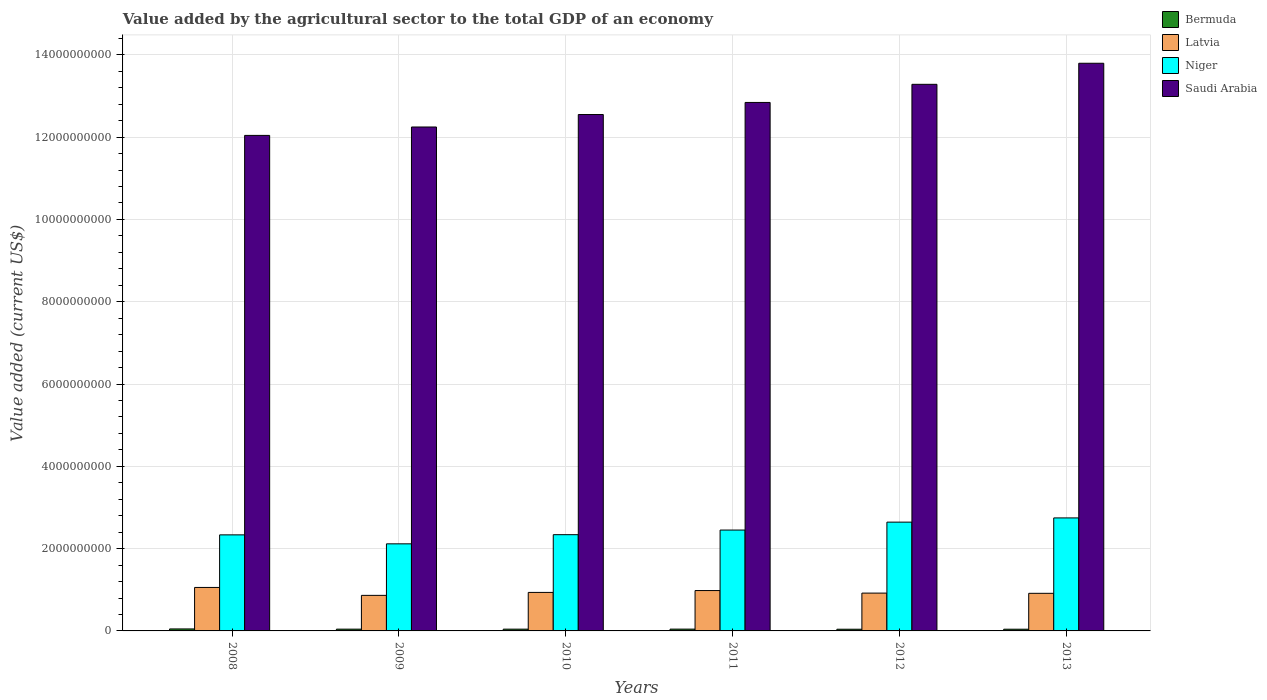How many different coloured bars are there?
Offer a terse response. 4. How many groups of bars are there?
Your answer should be compact. 6. Are the number of bars per tick equal to the number of legend labels?
Make the answer very short. Yes. Are the number of bars on each tick of the X-axis equal?
Offer a very short reply. Yes. What is the value added by the agricultural sector to the total GDP in Saudi Arabia in 2013?
Offer a terse response. 1.38e+1. Across all years, what is the maximum value added by the agricultural sector to the total GDP in Saudi Arabia?
Ensure brevity in your answer.  1.38e+1. Across all years, what is the minimum value added by the agricultural sector to the total GDP in Saudi Arabia?
Give a very brief answer. 1.20e+1. In which year was the value added by the agricultural sector to the total GDP in Latvia minimum?
Offer a terse response. 2009. What is the total value added by the agricultural sector to the total GDP in Saudi Arabia in the graph?
Provide a short and direct response. 7.68e+1. What is the difference between the value added by the agricultural sector to the total GDP in Niger in 2009 and that in 2013?
Make the answer very short. -6.30e+08. What is the difference between the value added by the agricultural sector to the total GDP in Saudi Arabia in 2011 and the value added by the agricultural sector to the total GDP in Bermuda in 2009?
Provide a short and direct response. 1.28e+1. What is the average value added by the agricultural sector to the total GDP in Latvia per year?
Ensure brevity in your answer.  9.45e+08. In the year 2013, what is the difference between the value added by the agricultural sector to the total GDP in Niger and value added by the agricultural sector to the total GDP in Latvia?
Provide a short and direct response. 1.83e+09. What is the ratio of the value added by the agricultural sector to the total GDP in Bermuda in 2009 to that in 2012?
Keep it short and to the point. 1.05. What is the difference between the highest and the second highest value added by the agricultural sector to the total GDP in Bermuda?
Your response must be concise. 4.52e+06. What is the difference between the highest and the lowest value added by the agricultural sector to the total GDP in Saudi Arabia?
Offer a very short reply. 1.75e+09. In how many years, is the value added by the agricultural sector to the total GDP in Latvia greater than the average value added by the agricultural sector to the total GDP in Latvia taken over all years?
Provide a succinct answer. 2. Is it the case that in every year, the sum of the value added by the agricultural sector to the total GDP in Bermuda and value added by the agricultural sector to the total GDP in Niger is greater than the sum of value added by the agricultural sector to the total GDP in Saudi Arabia and value added by the agricultural sector to the total GDP in Latvia?
Your response must be concise. Yes. What does the 4th bar from the left in 2009 represents?
Your answer should be very brief. Saudi Arabia. What does the 4th bar from the right in 2009 represents?
Make the answer very short. Bermuda. Is it the case that in every year, the sum of the value added by the agricultural sector to the total GDP in Saudi Arabia and value added by the agricultural sector to the total GDP in Latvia is greater than the value added by the agricultural sector to the total GDP in Bermuda?
Your answer should be very brief. Yes. How many years are there in the graph?
Make the answer very short. 6. What is the difference between two consecutive major ticks on the Y-axis?
Offer a terse response. 2.00e+09. Are the values on the major ticks of Y-axis written in scientific E-notation?
Your response must be concise. No. Does the graph contain grids?
Give a very brief answer. Yes. How many legend labels are there?
Your response must be concise. 4. How are the legend labels stacked?
Your response must be concise. Vertical. What is the title of the graph?
Your answer should be compact. Value added by the agricultural sector to the total GDP of an economy. What is the label or title of the X-axis?
Your answer should be compact. Years. What is the label or title of the Y-axis?
Your answer should be compact. Value added (current US$). What is the Value added (current US$) in Bermuda in 2008?
Provide a short and direct response. 4.83e+07. What is the Value added (current US$) of Latvia in 2008?
Offer a terse response. 1.06e+09. What is the Value added (current US$) in Niger in 2008?
Make the answer very short. 2.33e+09. What is the Value added (current US$) in Saudi Arabia in 2008?
Provide a succinct answer. 1.20e+1. What is the Value added (current US$) of Bermuda in 2009?
Give a very brief answer. 4.30e+07. What is the Value added (current US$) of Latvia in 2009?
Your answer should be compact. 8.64e+08. What is the Value added (current US$) in Niger in 2009?
Keep it short and to the point. 2.12e+09. What is the Value added (current US$) of Saudi Arabia in 2009?
Ensure brevity in your answer.  1.22e+1. What is the Value added (current US$) in Bermuda in 2010?
Make the answer very short. 4.30e+07. What is the Value added (current US$) in Latvia in 2010?
Offer a terse response. 9.36e+08. What is the Value added (current US$) in Niger in 2010?
Your response must be concise. 2.34e+09. What is the Value added (current US$) in Saudi Arabia in 2010?
Provide a short and direct response. 1.26e+1. What is the Value added (current US$) in Bermuda in 2011?
Your answer should be compact. 4.38e+07. What is the Value added (current US$) of Latvia in 2011?
Give a very brief answer. 9.81e+08. What is the Value added (current US$) in Niger in 2011?
Make the answer very short. 2.45e+09. What is the Value added (current US$) in Saudi Arabia in 2011?
Ensure brevity in your answer.  1.28e+1. What is the Value added (current US$) of Bermuda in 2012?
Ensure brevity in your answer.  4.10e+07. What is the Value added (current US$) in Latvia in 2012?
Offer a very short reply. 9.19e+08. What is the Value added (current US$) of Niger in 2012?
Keep it short and to the point. 2.64e+09. What is the Value added (current US$) of Saudi Arabia in 2012?
Keep it short and to the point. 1.33e+1. What is the Value added (current US$) of Bermuda in 2013?
Keep it short and to the point. 4.15e+07. What is the Value added (current US$) of Latvia in 2013?
Offer a very short reply. 9.14e+08. What is the Value added (current US$) in Niger in 2013?
Provide a succinct answer. 2.75e+09. What is the Value added (current US$) of Saudi Arabia in 2013?
Offer a terse response. 1.38e+1. Across all years, what is the maximum Value added (current US$) of Bermuda?
Keep it short and to the point. 4.83e+07. Across all years, what is the maximum Value added (current US$) in Latvia?
Provide a succinct answer. 1.06e+09. Across all years, what is the maximum Value added (current US$) in Niger?
Offer a very short reply. 2.75e+09. Across all years, what is the maximum Value added (current US$) in Saudi Arabia?
Your response must be concise. 1.38e+1. Across all years, what is the minimum Value added (current US$) of Bermuda?
Your answer should be very brief. 4.10e+07. Across all years, what is the minimum Value added (current US$) in Latvia?
Your answer should be compact. 8.64e+08. Across all years, what is the minimum Value added (current US$) of Niger?
Your response must be concise. 2.12e+09. Across all years, what is the minimum Value added (current US$) of Saudi Arabia?
Your response must be concise. 1.20e+1. What is the total Value added (current US$) in Bermuda in the graph?
Offer a very short reply. 2.61e+08. What is the total Value added (current US$) of Latvia in the graph?
Your response must be concise. 5.67e+09. What is the total Value added (current US$) in Niger in the graph?
Your response must be concise. 1.46e+1. What is the total Value added (current US$) in Saudi Arabia in the graph?
Make the answer very short. 7.68e+1. What is the difference between the Value added (current US$) in Bermuda in 2008 and that in 2009?
Ensure brevity in your answer.  5.31e+06. What is the difference between the Value added (current US$) in Latvia in 2008 and that in 2009?
Ensure brevity in your answer.  1.92e+08. What is the difference between the Value added (current US$) in Niger in 2008 and that in 2009?
Your response must be concise. 2.18e+08. What is the difference between the Value added (current US$) in Saudi Arabia in 2008 and that in 2009?
Offer a very short reply. -2.04e+08. What is the difference between the Value added (current US$) of Bermuda in 2008 and that in 2010?
Provide a short and direct response. 5.33e+06. What is the difference between the Value added (current US$) of Latvia in 2008 and that in 2010?
Provide a succinct answer. 1.21e+08. What is the difference between the Value added (current US$) of Niger in 2008 and that in 2010?
Your response must be concise. -4.26e+06. What is the difference between the Value added (current US$) in Saudi Arabia in 2008 and that in 2010?
Provide a short and direct response. -5.07e+08. What is the difference between the Value added (current US$) of Bermuda in 2008 and that in 2011?
Provide a succinct answer. 4.52e+06. What is the difference between the Value added (current US$) in Latvia in 2008 and that in 2011?
Provide a short and direct response. 7.56e+07. What is the difference between the Value added (current US$) in Niger in 2008 and that in 2011?
Keep it short and to the point. -1.17e+08. What is the difference between the Value added (current US$) in Saudi Arabia in 2008 and that in 2011?
Provide a short and direct response. -8.01e+08. What is the difference between the Value added (current US$) of Bermuda in 2008 and that in 2012?
Make the answer very short. 7.28e+06. What is the difference between the Value added (current US$) of Latvia in 2008 and that in 2012?
Your answer should be compact. 1.37e+08. What is the difference between the Value added (current US$) in Niger in 2008 and that in 2012?
Keep it short and to the point. -3.09e+08. What is the difference between the Value added (current US$) of Saudi Arabia in 2008 and that in 2012?
Ensure brevity in your answer.  -1.24e+09. What is the difference between the Value added (current US$) of Bermuda in 2008 and that in 2013?
Your answer should be compact. 6.76e+06. What is the difference between the Value added (current US$) in Latvia in 2008 and that in 2013?
Give a very brief answer. 1.43e+08. What is the difference between the Value added (current US$) of Niger in 2008 and that in 2013?
Make the answer very short. -4.12e+08. What is the difference between the Value added (current US$) of Saudi Arabia in 2008 and that in 2013?
Ensure brevity in your answer.  -1.75e+09. What is the difference between the Value added (current US$) in Bermuda in 2009 and that in 2010?
Offer a very short reply. 1.60e+04. What is the difference between the Value added (current US$) in Latvia in 2009 and that in 2010?
Provide a succinct answer. -7.16e+07. What is the difference between the Value added (current US$) of Niger in 2009 and that in 2010?
Offer a very short reply. -2.22e+08. What is the difference between the Value added (current US$) in Saudi Arabia in 2009 and that in 2010?
Provide a short and direct response. -3.03e+08. What is the difference between the Value added (current US$) in Bermuda in 2009 and that in 2011?
Your response must be concise. -7.95e+05. What is the difference between the Value added (current US$) of Latvia in 2009 and that in 2011?
Your answer should be very brief. -1.17e+08. What is the difference between the Value added (current US$) in Niger in 2009 and that in 2011?
Your answer should be compact. -3.35e+08. What is the difference between the Value added (current US$) of Saudi Arabia in 2009 and that in 2011?
Make the answer very short. -5.97e+08. What is the difference between the Value added (current US$) in Bermuda in 2009 and that in 2012?
Offer a terse response. 1.96e+06. What is the difference between the Value added (current US$) of Latvia in 2009 and that in 2012?
Provide a short and direct response. -5.51e+07. What is the difference between the Value added (current US$) of Niger in 2009 and that in 2012?
Your answer should be compact. -5.27e+08. What is the difference between the Value added (current US$) in Saudi Arabia in 2009 and that in 2012?
Make the answer very short. -1.04e+09. What is the difference between the Value added (current US$) in Bermuda in 2009 and that in 2013?
Provide a succinct answer. 1.45e+06. What is the difference between the Value added (current US$) of Latvia in 2009 and that in 2013?
Make the answer very short. -4.96e+07. What is the difference between the Value added (current US$) in Niger in 2009 and that in 2013?
Your answer should be compact. -6.30e+08. What is the difference between the Value added (current US$) of Saudi Arabia in 2009 and that in 2013?
Offer a terse response. -1.55e+09. What is the difference between the Value added (current US$) in Bermuda in 2010 and that in 2011?
Your answer should be very brief. -8.11e+05. What is the difference between the Value added (current US$) of Latvia in 2010 and that in 2011?
Your response must be concise. -4.52e+07. What is the difference between the Value added (current US$) in Niger in 2010 and that in 2011?
Make the answer very short. -1.13e+08. What is the difference between the Value added (current US$) in Saudi Arabia in 2010 and that in 2011?
Give a very brief answer. -2.93e+08. What is the difference between the Value added (current US$) of Bermuda in 2010 and that in 2012?
Keep it short and to the point. 1.95e+06. What is the difference between the Value added (current US$) of Latvia in 2010 and that in 2012?
Provide a succinct answer. 1.65e+07. What is the difference between the Value added (current US$) in Niger in 2010 and that in 2012?
Provide a succinct answer. -3.05e+08. What is the difference between the Value added (current US$) of Saudi Arabia in 2010 and that in 2012?
Your answer should be compact. -7.34e+08. What is the difference between the Value added (current US$) of Bermuda in 2010 and that in 2013?
Offer a terse response. 1.43e+06. What is the difference between the Value added (current US$) of Latvia in 2010 and that in 2013?
Provide a short and direct response. 2.20e+07. What is the difference between the Value added (current US$) of Niger in 2010 and that in 2013?
Offer a very short reply. -4.08e+08. What is the difference between the Value added (current US$) of Saudi Arabia in 2010 and that in 2013?
Make the answer very short. -1.25e+09. What is the difference between the Value added (current US$) of Bermuda in 2011 and that in 2012?
Give a very brief answer. 2.76e+06. What is the difference between the Value added (current US$) in Latvia in 2011 and that in 2012?
Your answer should be very brief. 6.18e+07. What is the difference between the Value added (current US$) in Niger in 2011 and that in 2012?
Provide a short and direct response. -1.92e+08. What is the difference between the Value added (current US$) of Saudi Arabia in 2011 and that in 2012?
Your answer should be compact. -4.41e+08. What is the difference between the Value added (current US$) of Bermuda in 2011 and that in 2013?
Provide a succinct answer. 2.24e+06. What is the difference between the Value added (current US$) in Latvia in 2011 and that in 2013?
Your answer should be compact. 6.73e+07. What is the difference between the Value added (current US$) in Niger in 2011 and that in 2013?
Provide a succinct answer. -2.95e+08. What is the difference between the Value added (current US$) of Saudi Arabia in 2011 and that in 2013?
Offer a very short reply. -9.53e+08. What is the difference between the Value added (current US$) in Bermuda in 2012 and that in 2013?
Provide a short and direct response. -5.16e+05. What is the difference between the Value added (current US$) in Latvia in 2012 and that in 2013?
Ensure brevity in your answer.  5.49e+06. What is the difference between the Value added (current US$) of Niger in 2012 and that in 2013?
Provide a succinct answer. -1.03e+08. What is the difference between the Value added (current US$) in Saudi Arabia in 2012 and that in 2013?
Your answer should be very brief. -5.12e+08. What is the difference between the Value added (current US$) in Bermuda in 2008 and the Value added (current US$) in Latvia in 2009?
Your response must be concise. -8.16e+08. What is the difference between the Value added (current US$) of Bermuda in 2008 and the Value added (current US$) of Niger in 2009?
Your answer should be very brief. -2.07e+09. What is the difference between the Value added (current US$) in Bermuda in 2008 and the Value added (current US$) in Saudi Arabia in 2009?
Your answer should be compact. -1.22e+1. What is the difference between the Value added (current US$) of Latvia in 2008 and the Value added (current US$) of Niger in 2009?
Make the answer very short. -1.06e+09. What is the difference between the Value added (current US$) of Latvia in 2008 and the Value added (current US$) of Saudi Arabia in 2009?
Keep it short and to the point. -1.12e+1. What is the difference between the Value added (current US$) in Niger in 2008 and the Value added (current US$) in Saudi Arabia in 2009?
Your answer should be compact. -9.91e+09. What is the difference between the Value added (current US$) of Bermuda in 2008 and the Value added (current US$) of Latvia in 2010?
Ensure brevity in your answer.  -8.88e+08. What is the difference between the Value added (current US$) of Bermuda in 2008 and the Value added (current US$) of Niger in 2010?
Your answer should be very brief. -2.29e+09. What is the difference between the Value added (current US$) of Bermuda in 2008 and the Value added (current US$) of Saudi Arabia in 2010?
Make the answer very short. -1.25e+1. What is the difference between the Value added (current US$) of Latvia in 2008 and the Value added (current US$) of Niger in 2010?
Your answer should be very brief. -1.28e+09. What is the difference between the Value added (current US$) in Latvia in 2008 and the Value added (current US$) in Saudi Arabia in 2010?
Offer a terse response. -1.15e+1. What is the difference between the Value added (current US$) in Niger in 2008 and the Value added (current US$) in Saudi Arabia in 2010?
Give a very brief answer. -1.02e+1. What is the difference between the Value added (current US$) of Bermuda in 2008 and the Value added (current US$) of Latvia in 2011?
Provide a succinct answer. -9.33e+08. What is the difference between the Value added (current US$) of Bermuda in 2008 and the Value added (current US$) of Niger in 2011?
Offer a terse response. -2.40e+09. What is the difference between the Value added (current US$) in Bermuda in 2008 and the Value added (current US$) in Saudi Arabia in 2011?
Your answer should be very brief. -1.28e+1. What is the difference between the Value added (current US$) of Latvia in 2008 and the Value added (current US$) of Niger in 2011?
Your response must be concise. -1.39e+09. What is the difference between the Value added (current US$) of Latvia in 2008 and the Value added (current US$) of Saudi Arabia in 2011?
Provide a short and direct response. -1.18e+1. What is the difference between the Value added (current US$) of Niger in 2008 and the Value added (current US$) of Saudi Arabia in 2011?
Make the answer very short. -1.05e+1. What is the difference between the Value added (current US$) in Bermuda in 2008 and the Value added (current US$) in Latvia in 2012?
Your answer should be compact. -8.71e+08. What is the difference between the Value added (current US$) of Bermuda in 2008 and the Value added (current US$) of Niger in 2012?
Make the answer very short. -2.60e+09. What is the difference between the Value added (current US$) in Bermuda in 2008 and the Value added (current US$) in Saudi Arabia in 2012?
Provide a short and direct response. -1.32e+1. What is the difference between the Value added (current US$) in Latvia in 2008 and the Value added (current US$) in Niger in 2012?
Provide a succinct answer. -1.59e+09. What is the difference between the Value added (current US$) of Latvia in 2008 and the Value added (current US$) of Saudi Arabia in 2012?
Your answer should be compact. -1.22e+1. What is the difference between the Value added (current US$) in Niger in 2008 and the Value added (current US$) in Saudi Arabia in 2012?
Provide a succinct answer. -1.09e+1. What is the difference between the Value added (current US$) in Bermuda in 2008 and the Value added (current US$) in Latvia in 2013?
Your answer should be compact. -8.66e+08. What is the difference between the Value added (current US$) of Bermuda in 2008 and the Value added (current US$) of Niger in 2013?
Give a very brief answer. -2.70e+09. What is the difference between the Value added (current US$) of Bermuda in 2008 and the Value added (current US$) of Saudi Arabia in 2013?
Keep it short and to the point. -1.37e+1. What is the difference between the Value added (current US$) in Latvia in 2008 and the Value added (current US$) in Niger in 2013?
Provide a succinct answer. -1.69e+09. What is the difference between the Value added (current US$) of Latvia in 2008 and the Value added (current US$) of Saudi Arabia in 2013?
Your answer should be compact. -1.27e+1. What is the difference between the Value added (current US$) of Niger in 2008 and the Value added (current US$) of Saudi Arabia in 2013?
Provide a succinct answer. -1.15e+1. What is the difference between the Value added (current US$) of Bermuda in 2009 and the Value added (current US$) of Latvia in 2010?
Provide a succinct answer. -8.93e+08. What is the difference between the Value added (current US$) of Bermuda in 2009 and the Value added (current US$) of Niger in 2010?
Your response must be concise. -2.30e+09. What is the difference between the Value added (current US$) in Bermuda in 2009 and the Value added (current US$) in Saudi Arabia in 2010?
Offer a terse response. -1.25e+1. What is the difference between the Value added (current US$) in Latvia in 2009 and the Value added (current US$) in Niger in 2010?
Make the answer very short. -1.47e+09. What is the difference between the Value added (current US$) in Latvia in 2009 and the Value added (current US$) in Saudi Arabia in 2010?
Provide a succinct answer. -1.17e+1. What is the difference between the Value added (current US$) of Niger in 2009 and the Value added (current US$) of Saudi Arabia in 2010?
Provide a succinct answer. -1.04e+1. What is the difference between the Value added (current US$) in Bermuda in 2009 and the Value added (current US$) in Latvia in 2011?
Provide a short and direct response. -9.38e+08. What is the difference between the Value added (current US$) in Bermuda in 2009 and the Value added (current US$) in Niger in 2011?
Provide a succinct answer. -2.41e+09. What is the difference between the Value added (current US$) in Bermuda in 2009 and the Value added (current US$) in Saudi Arabia in 2011?
Offer a terse response. -1.28e+1. What is the difference between the Value added (current US$) of Latvia in 2009 and the Value added (current US$) of Niger in 2011?
Make the answer very short. -1.59e+09. What is the difference between the Value added (current US$) of Latvia in 2009 and the Value added (current US$) of Saudi Arabia in 2011?
Your response must be concise. -1.20e+1. What is the difference between the Value added (current US$) in Niger in 2009 and the Value added (current US$) in Saudi Arabia in 2011?
Ensure brevity in your answer.  -1.07e+1. What is the difference between the Value added (current US$) of Bermuda in 2009 and the Value added (current US$) of Latvia in 2012?
Give a very brief answer. -8.76e+08. What is the difference between the Value added (current US$) of Bermuda in 2009 and the Value added (current US$) of Niger in 2012?
Ensure brevity in your answer.  -2.60e+09. What is the difference between the Value added (current US$) of Bermuda in 2009 and the Value added (current US$) of Saudi Arabia in 2012?
Keep it short and to the point. -1.32e+1. What is the difference between the Value added (current US$) of Latvia in 2009 and the Value added (current US$) of Niger in 2012?
Make the answer very short. -1.78e+09. What is the difference between the Value added (current US$) of Latvia in 2009 and the Value added (current US$) of Saudi Arabia in 2012?
Ensure brevity in your answer.  -1.24e+1. What is the difference between the Value added (current US$) in Niger in 2009 and the Value added (current US$) in Saudi Arabia in 2012?
Your answer should be very brief. -1.12e+1. What is the difference between the Value added (current US$) in Bermuda in 2009 and the Value added (current US$) in Latvia in 2013?
Ensure brevity in your answer.  -8.71e+08. What is the difference between the Value added (current US$) in Bermuda in 2009 and the Value added (current US$) in Niger in 2013?
Your response must be concise. -2.70e+09. What is the difference between the Value added (current US$) in Bermuda in 2009 and the Value added (current US$) in Saudi Arabia in 2013?
Offer a very short reply. -1.38e+1. What is the difference between the Value added (current US$) of Latvia in 2009 and the Value added (current US$) of Niger in 2013?
Your answer should be compact. -1.88e+09. What is the difference between the Value added (current US$) of Latvia in 2009 and the Value added (current US$) of Saudi Arabia in 2013?
Offer a terse response. -1.29e+1. What is the difference between the Value added (current US$) of Niger in 2009 and the Value added (current US$) of Saudi Arabia in 2013?
Offer a terse response. -1.17e+1. What is the difference between the Value added (current US$) in Bermuda in 2010 and the Value added (current US$) in Latvia in 2011?
Offer a terse response. -9.38e+08. What is the difference between the Value added (current US$) in Bermuda in 2010 and the Value added (current US$) in Niger in 2011?
Give a very brief answer. -2.41e+09. What is the difference between the Value added (current US$) in Bermuda in 2010 and the Value added (current US$) in Saudi Arabia in 2011?
Your answer should be compact. -1.28e+1. What is the difference between the Value added (current US$) in Latvia in 2010 and the Value added (current US$) in Niger in 2011?
Your response must be concise. -1.52e+09. What is the difference between the Value added (current US$) in Latvia in 2010 and the Value added (current US$) in Saudi Arabia in 2011?
Offer a very short reply. -1.19e+1. What is the difference between the Value added (current US$) of Niger in 2010 and the Value added (current US$) of Saudi Arabia in 2011?
Keep it short and to the point. -1.05e+1. What is the difference between the Value added (current US$) of Bermuda in 2010 and the Value added (current US$) of Latvia in 2012?
Give a very brief answer. -8.76e+08. What is the difference between the Value added (current US$) of Bermuda in 2010 and the Value added (current US$) of Niger in 2012?
Keep it short and to the point. -2.60e+09. What is the difference between the Value added (current US$) in Bermuda in 2010 and the Value added (current US$) in Saudi Arabia in 2012?
Give a very brief answer. -1.32e+1. What is the difference between the Value added (current US$) in Latvia in 2010 and the Value added (current US$) in Niger in 2012?
Offer a very short reply. -1.71e+09. What is the difference between the Value added (current US$) of Latvia in 2010 and the Value added (current US$) of Saudi Arabia in 2012?
Your answer should be compact. -1.23e+1. What is the difference between the Value added (current US$) of Niger in 2010 and the Value added (current US$) of Saudi Arabia in 2012?
Your answer should be compact. -1.09e+1. What is the difference between the Value added (current US$) in Bermuda in 2010 and the Value added (current US$) in Latvia in 2013?
Provide a short and direct response. -8.71e+08. What is the difference between the Value added (current US$) in Bermuda in 2010 and the Value added (current US$) in Niger in 2013?
Your answer should be compact. -2.70e+09. What is the difference between the Value added (current US$) of Bermuda in 2010 and the Value added (current US$) of Saudi Arabia in 2013?
Make the answer very short. -1.38e+1. What is the difference between the Value added (current US$) of Latvia in 2010 and the Value added (current US$) of Niger in 2013?
Ensure brevity in your answer.  -1.81e+09. What is the difference between the Value added (current US$) in Latvia in 2010 and the Value added (current US$) in Saudi Arabia in 2013?
Keep it short and to the point. -1.29e+1. What is the difference between the Value added (current US$) of Niger in 2010 and the Value added (current US$) of Saudi Arabia in 2013?
Give a very brief answer. -1.15e+1. What is the difference between the Value added (current US$) in Bermuda in 2011 and the Value added (current US$) in Latvia in 2012?
Your answer should be very brief. -8.76e+08. What is the difference between the Value added (current US$) of Bermuda in 2011 and the Value added (current US$) of Niger in 2012?
Provide a short and direct response. -2.60e+09. What is the difference between the Value added (current US$) of Bermuda in 2011 and the Value added (current US$) of Saudi Arabia in 2012?
Give a very brief answer. -1.32e+1. What is the difference between the Value added (current US$) of Latvia in 2011 and the Value added (current US$) of Niger in 2012?
Keep it short and to the point. -1.66e+09. What is the difference between the Value added (current US$) of Latvia in 2011 and the Value added (current US$) of Saudi Arabia in 2012?
Keep it short and to the point. -1.23e+1. What is the difference between the Value added (current US$) in Niger in 2011 and the Value added (current US$) in Saudi Arabia in 2012?
Keep it short and to the point. -1.08e+1. What is the difference between the Value added (current US$) in Bermuda in 2011 and the Value added (current US$) in Latvia in 2013?
Ensure brevity in your answer.  -8.70e+08. What is the difference between the Value added (current US$) of Bermuda in 2011 and the Value added (current US$) of Niger in 2013?
Make the answer very short. -2.70e+09. What is the difference between the Value added (current US$) of Bermuda in 2011 and the Value added (current US$) of Saudi Arabia in 2013?
Your answer should be very brief. -1.38e+1. What is the difference between the Value added (current US$) of Latvia in 2011 and the Value added (current US$) of Niger in 2013?
Provide a short and direct response. -1.77e+09. What is the difference between the Value added (current US$) of Latvia in 2011 and the Value added (current US$) of Saudi Arabia in 2013?
Provide a short and direct response. -1.28e+1. What is the difference between the Value added (current US$) of Niger in 2011 and the Value added (current US$) of Saudi Arabia in 2013?
Provide a short and direct response. -1.13e+1. What is the difference between the Value added (current US$) of Bermuda in 2012 and the Value added (current US$) of Latvia in 2013?
Provide a succinct answer. -8.73e+08. What is the difference between the Value added (current US$) in Bermuda in 2012 and the Value added (current US$) in Niger in 2013?
Your response must be concise. -2.71e+09. What is the difference between the Value added (current US$) in Bermuda in 2012 and the Value added (current US$) in Saudi Arabia in 2013?
Keep it short and to the point. -1.38e+1. What is the difference between the Value added (current US$) of Latvia in 2012 and the Value added (current US$) of Niger in 2013?
Provide a short and direct response. -1.83e+09. What is the difference between the Value added (current US$) of Latvia in 2012 and the Value added (current US$) of Saudi Arabia in 2013?
Offer a very short reply. -1.29e+1. What is the difference between the Value added (current US$) of Niger in 2012 and the Value added (current US$) of Saudi Arabia in 2013?
Provide a short and direct response. -1.12e+1. What is the average Value added (current US$) in Bermuda per year?
Your answer should be compact. 4.34e+07. What is the average Value added (current US$) of Latvia per year?
Provide a succinct answer. 9.45e+08. What is the average Value added (current US$) in Niger per year?
Provide a succinct answer. 2.44e+09. What is the average Value added (current US$) in Saudi Arabia per year?
Provide a succinct answer. 1.28e+1. In the year 2008, what is the difference between the Value added (current US$) in Bermuda and Value added (current US$) in Latvia?
Your answer should be compact. -1.01e+09. In the year 2008, what is the difference between the Value added (current US$) of Bermuda and Value added (current US$) of Niger?
Make the answer very short. -2.29e+09. In the year 2008, what is the difference between the Value added (current US$) in Bermuda and Value added (current US$) in Saudi Arabia?
Keep it short and to the point. -1.20e+1. In the year 2008, what is the difference between the Value added (current US$) of Latvia and Value added (current US$) of Niger?
Your response must be concise. -1.28e+09. In the year 2008, what is the difference between the Value added (current US$) in Latvia and Value added (current US$) in Saudi Arabia?
Provide a short and direct response. -1.10e+1. In the year 2008, what is the difference between the Value added (current US$) in Niger and Value added (current US$) in Saudi Arabia?
Provide a short and direct response. -9.71e+09. In the year 2009, what is the difference between the Value added (current US$) of Bermuda and Value added (current US$) of Latvia?
Offer a very short reply. -8.21e+08. In the year 2009, what is the difference between the Value added (current US$) of Bermuda and Value added (current US$) of Niger?
Provide a short and direct response. -2.07e+09. In the year 2009, what is the difference between the Value added (current US$) of Bermuda and Value added (current US$) of Saudi Arabia?
Offer a very short reply. -1.22e+1. In the year 2009, what is the difference between the Value added (current US$) in Latvia and Value added (current US$) in Niger?
Give a very brief answer. -1.25e+09. In the year 2009, what is the difference between the Value added (current US$) of Latvia and Value added (current US$) of Saudi Arabia?
Keep it short and to the point. -1.14e+1. In the year 2009, what is the difference between the Value added (current US$) of Niger and Value added (current US$) of Saudi Arabia?
Provide a short and direct response. -1.01e+1. In the year 2010, what is the difference between the Value added (current US$) of Bermuda and Value added (current US$) of Latvia?
Offer a very short reply. -8.93e+08. In the year 2010, what is the difference between the Value added (current US$) in Bermuda and Value added (current US$) in Niger?
Ensure brevity in your answer.  -2.30e+09. In the year 2010, what is the difference between the Value added (current US$) of Bermuda and Value added (current US$) of Saudi Arabia?
Provide a short and direct response. -1.25e+1. In the year 2010, what is the difference between the Value added (current US$) in Latvia and Value added (current US$) in Niger?
Offer a terse response. -1.40e+09. In the year 2010, what is the difference between the Value added (current US$) of Latvia and Value added (current US$) of Saudi Arabia?
Provide a short and direct response. -1.16e+1. In the year 2010, what is the difference between the Value added (current US$) of Niger and Value added (current US$) of Saudi Arabia?
Offer a terse response. -1.02e+1. In the year 2011, what is the difference between the Value added (current US$) of Bermuda and Value added (current US$) of Latvia?
Give a very brief answer. -9.37e+08. In the year 2011, what is the difference between the Value added (current US$) in Bermuda and Value added (current US$) in Niger?
Your answer should be compact. -2.41e+09. In the year 2011, what is the difference between the Value added (current US$) of Bermuda and Value added (current US$) of Saudi Arabia?
Offer a terse response. -1.28e+1. In the year 2011, what is the difference between the Value added (current US$) in Latvia and Value added (current US$) in Niger?
Make the answer very short. -1.47e+09. In the year 2011, what is the difference between the Value added (current US$) in Latvia and Value added (current US$) in Saudi Arabia?
Your response must be concise. -1.19e+1. In the year 2011, what is the difference between the Value added (current US$) of Niger and Value added (current US$) of Saudi Arabia?
Offer a terse response. -1.04e+1. In the year 2012, what is the difference between the Value added (current US$) in Bermuda and Value added (current US$) in Latvia?
Your response must be concise. -8.78e+08. In the year 2012, what is the difference between the Value added (current US$) in Bermuda and Value added (current US$) in Niger?
Ensure brevity in your answer.  -2.60e+09. In the year 2012, what is the difference between the Value added (current US$) of Bermuda and Value added (current US$) of Saudi Arabia?
Give a very brief answer. -1.32e+1. In the year 2012, what is the difference between the Value added (current US$) in Latvia and Value added (current US$) in Niger?
Make the answer very short. -1.72e+09. In the year 2012, what is the difference between the Value added (current US$) of Latvia and Value added (current US$) of Saudi Arabia?
Provide a short and direct response. -1.24e+1. In the year 2012, what is the difference between the Value added (current US$) of Niger and Value added (current US$) of Saudi Arabia?
Offer a very short reply. -1.06e+1. In the year 2013, what is the difference between the Value added (current US$) of Bermuda and Value added (current US$) of Latvia?
Ensure brevity in your answer.  -8.72e+08. In the year 2013, what is the difference between the Value added (current US$) in Bermuda and Value added (current US$) in Niger?
Make the answer very short. -2.70e+09. In the year 2013, what is the difference between the Value added (current US$) of Bermuda and Value added (current US$) of Saudi Arabia?
Make the answer very short. -1.38e+1. In the year 2013, what is the difference between the Value added (current US$) in Latvia and Value added (current US$) in Niger?
Make the answer very short. -1.83e+09. In the year 2013, what is the difference between the Value added (current US$) in Latvia and Value added (current US$) in Saudi Arabia?
Ensure brevity in your answer.  -1.29e+1. In the year 2013, what is the difference between the Value added (current US$) in Niger and Value added (current US$) in Saudi Arabia?
Ensure brevity in your answer.  -1.10e+1. What is the ratio of the Value added (current US$) of Bermuda in 2008 to that in 2009?
Keep it short and to the point. 1.12. What is the ratio of the Value added (current US$) of Latvia in 2008 to that in 2009?
Keep it short and to the point. 1.22. What is the ratio of the Value added (current US$) in Niger in 2008 to that in 2009?
Offer a terse response. 1.1. What is the ratio of the Value added (current US$) in Saudi Arabia in 2008 to that in 2009?
Provide a short and direct response. 0.98. What is the ratio of the Value added (current US$) of Bermuda in 2008 to that in 2010?
Provide a succinct answer. 1.12. What is the ratio of the Value added (current US$) of Latvia in 2008 to that in 2010?
Provide a succinct answer. 1.13. What is the ratio of the Value added (current US$) in Niger in 2008 to that in 2010?
Ensure brevity in your answer.  1. What is the ratio of the Value added (current US$) in Saudi Arabia in 2008 to that in 2010?
Keep it short and to the point. 0.96. What is the ratio of the Value added (current US$) of Bermuda in 2008 to that in 2011?
Provide a succinct answer. 1.1. What is the ratio of the Value added (current US$) of Latvia in 2008 to that in 2011?
Give a very brief answer. 1.08. What is the ratio of the Value added (current US$) of Niger in 2008 to that in 2011?
Provide a succinct answer. 0.95. What is the ratio of the Value added (current US$) of Saudi Arabia in 2008 to that in 2011?
Provide a short and direct response. 0.94. What is the ratio of the Value added (current US$) of Bermuda in 2008 to that in 2012?
Your response must be concise. 1.18. What is the ratio of the Value added (current US$) of Latvia in 2008 to that in 2012?
Ensure brevity in your answer.  1.15. What is the ratio of the Value added (current US$) of Niger in 2008 to that in 2012?
Offer a very short reply. 0.88. What is the ratio of the Value added (current US$) in Saudi Arabia in 2008 to that in 2012?
Offer a terse response. 0.91. What is the ratio of the Value added (current US$) in Bermuda in 2008 to that in 2013?
Offer a terse response. 1.16. What is the ratio of the Value added (current US$) in Latvia in 2008 to that in 2013?
Offer a terse response. 1.16. What is the ratio of the Value added (current US$) in Niger in 2008 to that in 2013?
Your answer should be compact. 0.85. What is the ratio of the Value added (current US$) in Saudi Arabia in 2008 to that in 2013?
Offer a terse response. 0.87. What is the ratio of the Value added (current US$) in Latvia in 2009 to that in 2010?
Offer a very short reply. 0.92. What is the ratio of the Value added (current US$) of Niger in 2009 to that in 2010?
Offer a very short reply. 0.9. What is the ratio of the Value added (current US$) in Saudi Arabia in 2009 to that in 2010?
Ensure brevity in your answer.  0.98. What is the ratio of the Value added (current US$) of Bermuda in 2009 to that in 2011?
Make the answer very short. 0.98. What is the ratio of the Value added (current US$) of Latvia in 2009 to that in 2011?
Your answer should be compact. 0.88. What is the ratio of the Value added (current US$) in Niger in 2009 to that in 2011?
Offer a terse response. 0.86. What is the ratio of the Value added (current US$) of Saudi Arabia in 2009 to that in 2011?
Offer a very short reply. 0.95. What is the ratio of the Value added (current US$) in Bermuda in 2009 to that in 2012?
Your answer should be compact. 1.05. What is the ratio of the Value added (current US$) of Latvia in 2009 to that in 2012?
Provide a succinct answer. 0.94. What is the ratio of the Value added (current US$) in Niger in 2009 to that in 2012?
Your answer should be very brief. 0.8. What is the ratio of the Value added (current US$) in Saudi Arabia in 2009 to that in 2012?
Your response must be concise. 0.92. What is the ratio of the Value added (current US$) of Bermuda in 2009 to that in 2013?
Give a very brief answer. 1.03. What is the ratio of the Value added (current US$) in Latvia in 2009 to that in 2013?
Offer a terse response. 0.95. What is the ratio of the Value added (current US$) in Niger in 2009 to that in 2013?
Provide a succinct answer. 0.77. What is the ratio of the Value added (current US$) in Saudi Arabia in 2009 to that in 2013?
Offer a very short reply. 0.89. What is the ratio of the Value added (current US$) in Bermuda in 2010 to that in 2011?
Your response must be concise. 0.98. What is the ratio of the Value added (current US$) in Latvia in 2010 to that in 2011?
Make the answer very short. 0.95. What is the ratio of the Value added (current US$) in Niger in 2010 to that in 2011?
Your answer should be compact. 0.95. What is the ratio of the Value added (current US$) of Saudi Arabia in 2010 to that in 2011?
Give a very brief answer. 0.98. What is the ratio of the Value added (current US$) of Bermuda in 2010 to that in 2012?
Provide a short and direct response. 1.05. What is the ratio of the Value added (current US$) in Latvia in 2010 to that in 2012?
Your answer should be compact. 1.02. What is the ratio of the Value added (current US$) of Niger in 2010 to that in 2012?
Give a very brief answer. 0.88. What is the ratio of the Value added (current US$) of Saudi Arabia in 2010 to that in 2012?
Your answer should be compact. 0.94. What is the ratio of the Value added (current US$) of Bermuda in 2010 to that in 2013?
Keep it short and to the point. 1.03. What is the ratio of the Value added (current US$) of Latvia in 2010 to that in 2013?
Your answer should be compact. 1.02. What is the ratio of the Value added (current US$) of Niger in 2010 to that in 2013?
Ensure brevity in your answer.  0.85. What is the ratio of the Value added (current US$) of Saudi Arabia in 2010 to that in 2013?
Offer a very short reply. 0.91. What is the ratio of the Value added (current US$) of Bermuda in 2011 to that in 2012?
Your answer should be compact. 1.07. What is the ratio of the Value added (current US$) in Latvia in 2011 to that in 2012?
Provide a short and direct response. 1.07. What is the ratio of the Value added (current US$) in Niger in 2011 to that in 2012?
Provide a succinct answer. 0.93. What is the ratio of the Value added (current US$) in Saudi Arabia in 2011 to that in 2012?
Provide a succinct answer. 0.97. What is the ratio of the Value added (current US$) in Bermuda in 2011 to that in 2013?
Give a very brief answer. 1.05. What is the ratio of the Value added (current US$) in Latvia in 2011 to that in 2013?
Offer a terse response. 1.07. What is the ratio of the Value added (current US$) of Niger in 2011 to that in 2013?
Give a very brief answer. 0.89. What is the ratio of the Value added (current US$) of Saudi Arabia in 2011 to that in 2013?
Make the answer very short. 0.93. What is the ratio of the Value added (current US$) of Bermuda in 2012 to that in 2013?
Your answer should be very brief. 0.99. What is the ratio of the Value added (current US$) of Latvia in 2012 to that in 2013?
Offer a terse response. 1.01. What is the ratio of the Value added (current US$) of Niger in 2012 to that in 2013?
Make the answer very short. 0.96. What is the ratio of the Value added (current US$) of Saudi Arabia in 2012 to that in 2013?
Your answer should be very brief. 0.96. What is the difference between the highest and the second highest Value added (current US$) in Bermuda?
Make the answer very short. 4.52e+06. What is the difference between the highest and the second highest Value added (current US$) in Latvia?
Keep it short and to the point. 7.56e+07. What is the difference between the highest and the second highest Value added (current US$) of Niger?
Your answer should be very brief. 1.03e+08. What is the difference between the highest and the second highest Value added (current US$) of Saudi Arabia?
Keep it short and to the point. 5.12e+08. What is the difference between the highest and the lowest Value added (current US$) of Bermuda?
Ensure brevity in your answer.  7.28e+06. What is the difference between the highest and the lowest Value added (current US$) of Latvia?
Ensure brevity in your answer.  1.92e+08. What is the difference between the highest and the lowest Value added (current US$) in Niger?
Your answer should be compact. 6.30e+08. What is the difference between the highest and the lowest Value added (current US$) of Saudi Arabia?
Make the answer very short. 1.75e+09. 